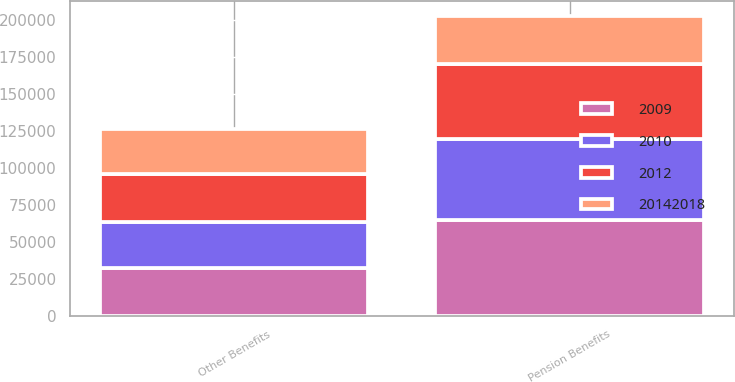Convert chart to OTSL. <chart><loc_0><loc_0><loc_500><loc_500><stacked_bar_chart><ecel><fcel>Pension Benefits<fcel>Other Benefits<nl><fcel>2.0142e+07<fcel>32426<fcel>30399<nl><fcel>2009<fcel>64939<fcel>32125<nl><fcel>2012<fcel>51325<fcel>32426<nl><fcel>2010<fcel>54398<fcel>31476<nl></chart> 